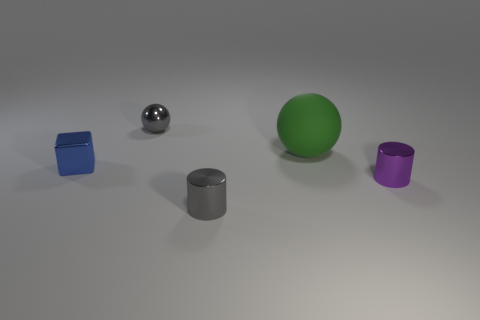Can you tell me what objects are seen in the image and their colors? Certainly! In the image, we see a collection of objects including a large green rubber ball, a smaller silver sphere, a blue cube, a grey cylinder, and a purple cylinder with a similar shape but different hue. 